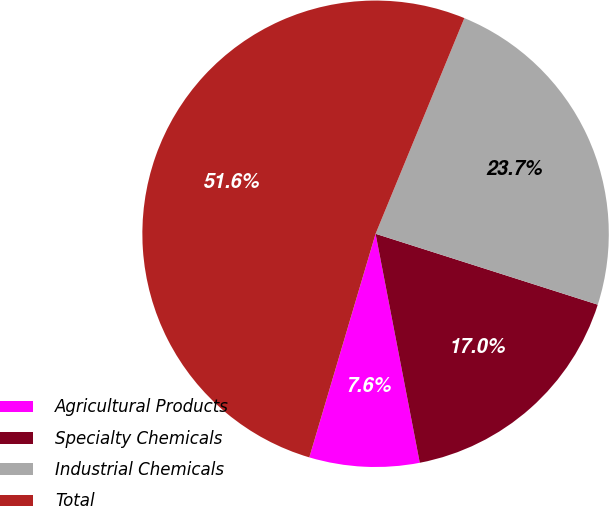Convert chart to OTSL. <chart><loc_0><loc_0><loc_500><loc_500><pie_chart><fcel>Agricultural Products<fcel>Specialty Chemicals<fcel>Industrial Chemicals<fcel>Total<nl><fcel>7.62%<fcel>17.05%<fcel>23.7%<fcel>51.63%<nl></chart> 